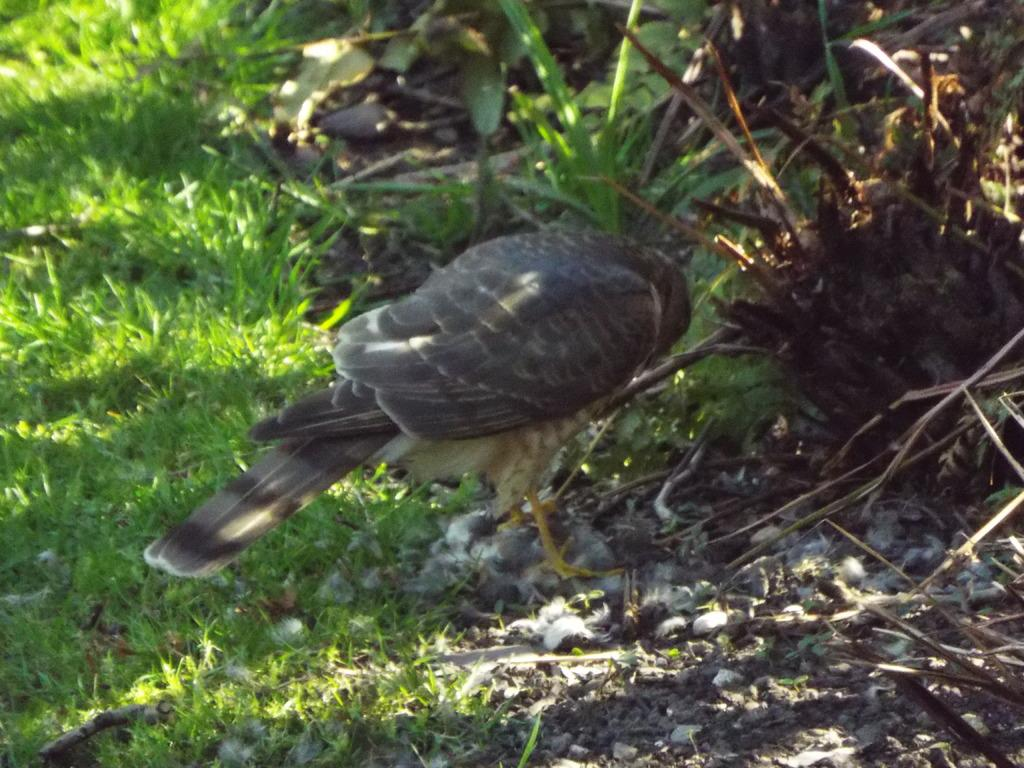What type of bird can be seen in the image? There is a grey and black color bird in the image. Where is the bird located in the image? The bird is standing on the land. What type of vegetation is present on the left side of the image? Grass is present on the left side of the image. What type of stone is the bird sitting on in the image? There is no stone present in the image; the bird is standing on the land. What shape is the gate visible in the image? There is no gate present in the image. 